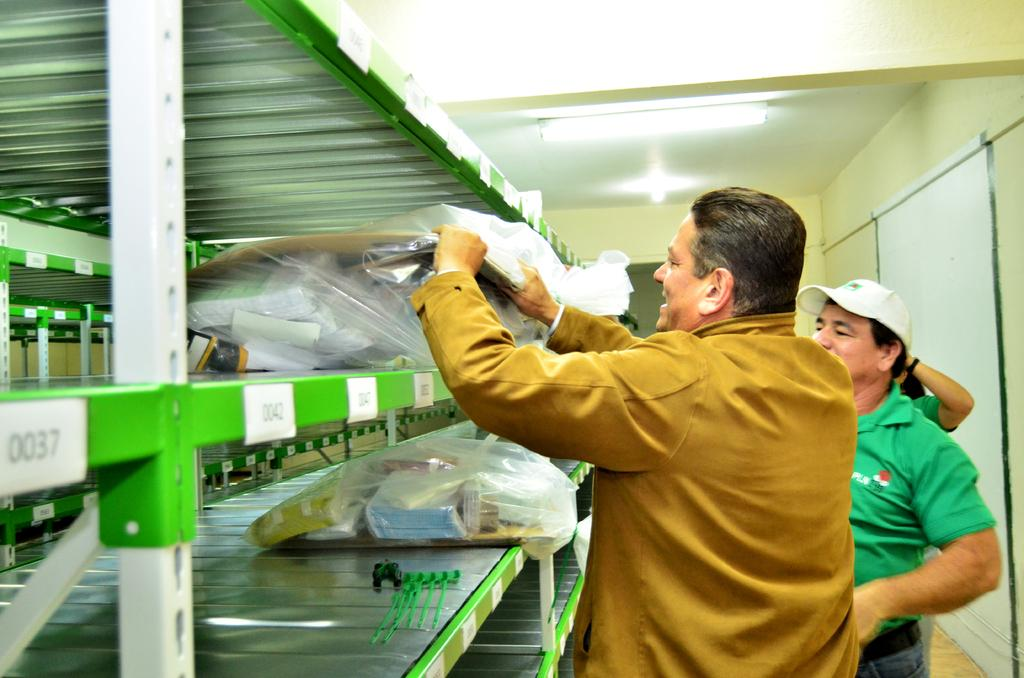What are the people in the image doing? The people are standing in front of a rack with things inside covers. What can be seen on the ceiling in the image? There are lights over the ceiling. Where was the image taken? The image was taken inside a room. What type of advice can be seen written on the sidewalk outside the room in the image? There is no sidewalk or advice visible in the image; it was taken inside a room with a rack and lights on the ceiling. 